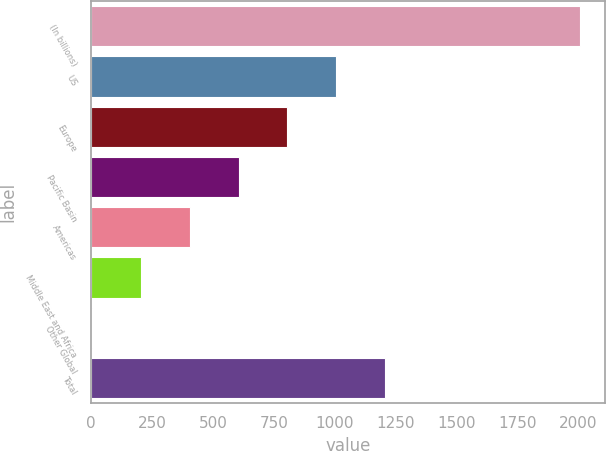Convert chart to OTSL. <chart><loc_0><loc_0><loc_500><loc_500><bar_chart><fcel>(In billions)<fcel>US<fcel>Europe<fcel>Pacific Basin<fcel>Americas<fcel>Middle East and Africa<fcel>Other Global<fcel>Total<nl><fcel>2009<fcel>1006.55<fcel>806.06<fcel>605.57<fcel>405.08<fcel>204.59<fcel>4.1<fcel>1207.04<nl></chart> 